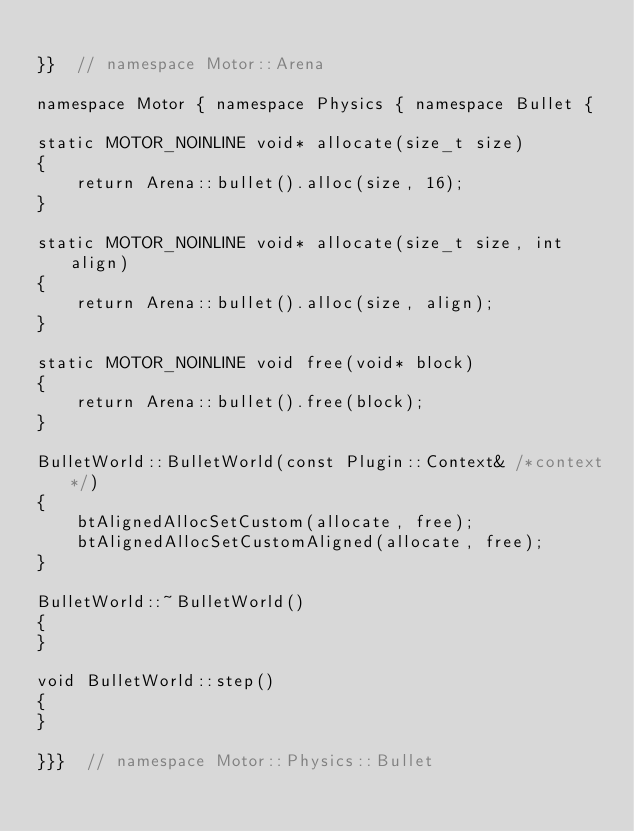Convert code to text. <code><loc_0><loc_0><loc_500><loc_500><_C++_>
}}  // namespace Motor::Arena

namespace Motor { namespace Physics { namespace Bullet {

static MOTOR_NOINLINE void* allocate(size_t size)
{
    return Arena::bullet().alloc(size, 16);
}

static MOTOR_NOINLINE void* allocate(size_t size, int align)
{
    return Arena::bullet().alloc(size, align);
}

static MOTOR_NOINLINE void free(void* block)
{
    return Arena::bullet().free(block);
}

BulletWorld::BulletWorld(const Plugin::Context& /*context*/)
{
    btAlignedAllocSetCustom(allocate, free);
    btAlignedAllocSetCustomAligned(allocate, free);
}

BulletWorld::~BulletWorld()
{
}

void BulletWorld::step()
{
}

}}}  // namespace Motor::Physics::Bullet
</code> 